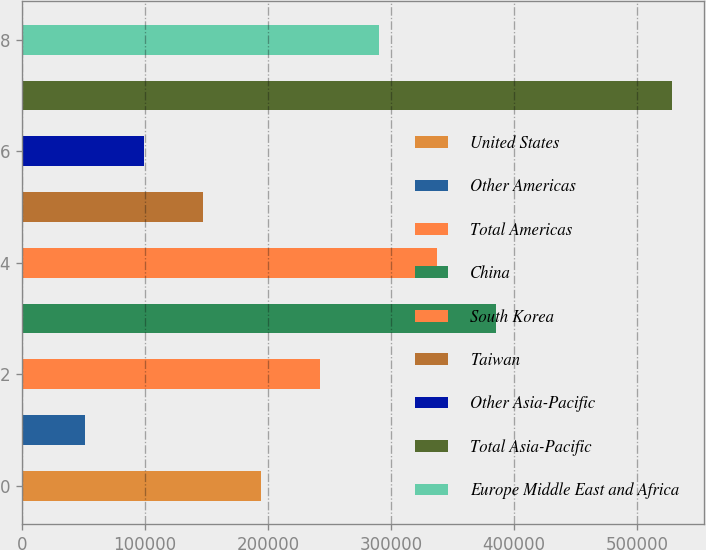Convert chart. <chart><loc_0><loc_0><loc_500><loc_500><bar_chart><fcel>United States<fcel>Other Americas<fcel>Total Americas<fcel>China<fcel>South Korea<fcel>Taiwan<fcel>Other Asia-Pacific<fcel>Total Asia-Pacific<fcel>Europe Middle East and Africa<nl><fcel>194521<fcel>51537<fcel>242182<fcel>385166<fcel>337505<fcel>146860<fcel>99198.3<fcel>528150<fcel>289844<nl></chart> 